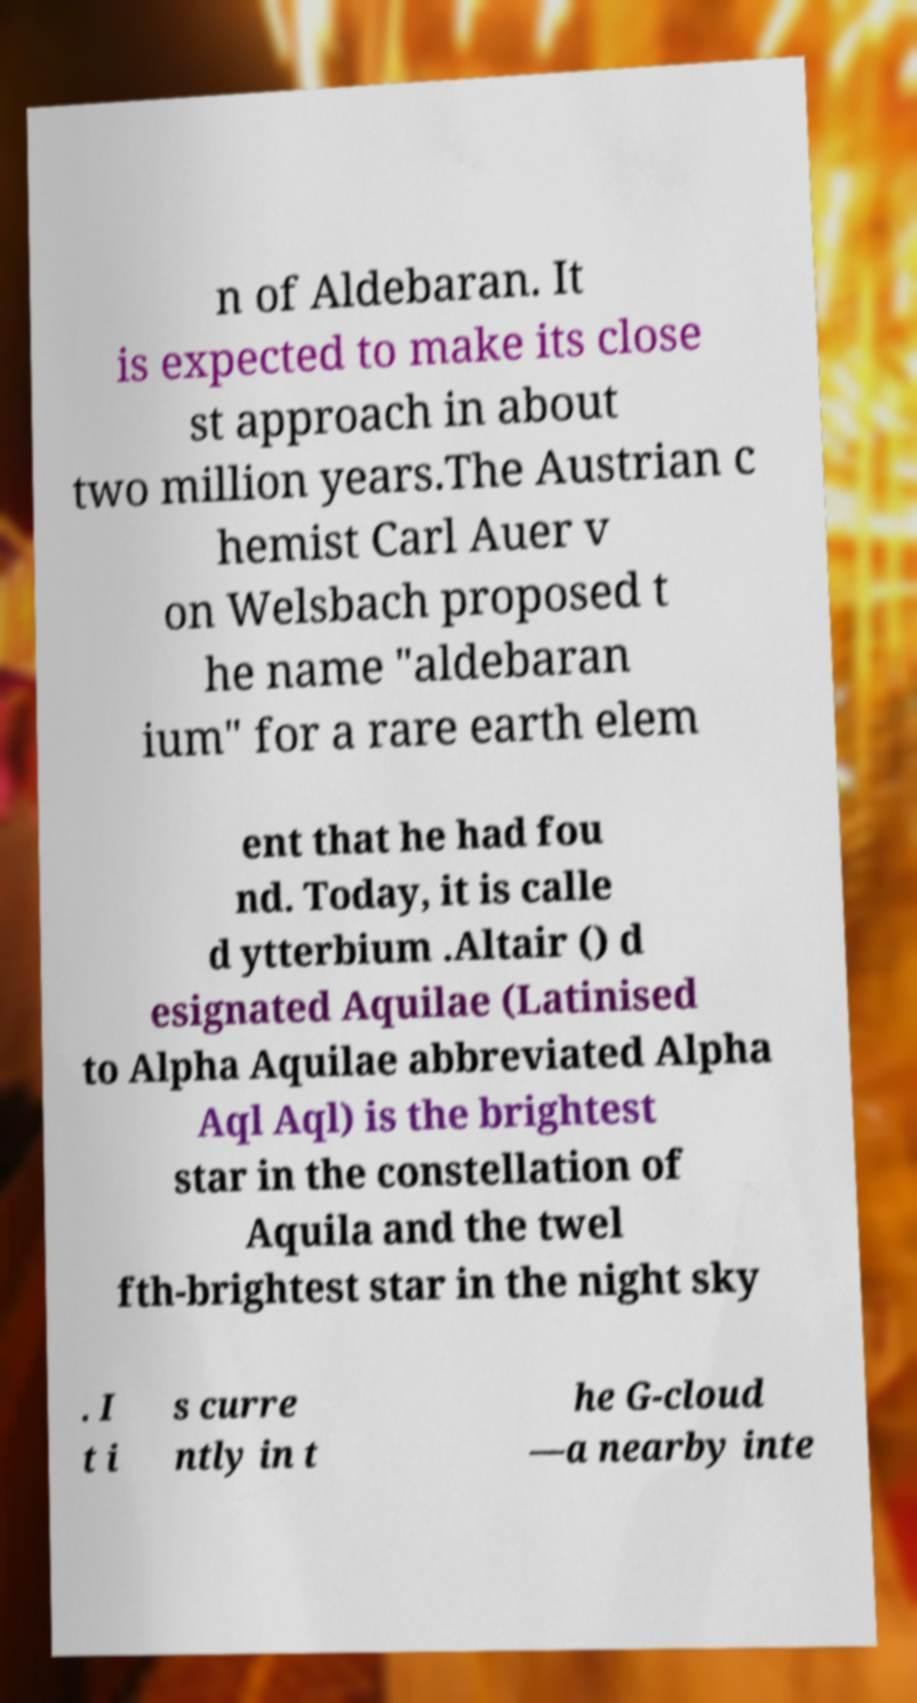I need the written content from this picture converted into text. Can you do that? n of Aldebaran. It is expected to make its close st approach in about two million years.The Austrian c hemist Carl Auer v on Welsbach proposed t he name "aldebaran ium" for a rare earth elem ent that he had fou nd. Today, it is calle d ytterbium .Altair () d esignated Aquilae (Latinised to Alpha Aquilae abbreviated Alpha Aql Aql) is the brightest star in the constellation of Aquila and the twel fth-brightest star in the night sky . I t i s curre ntly in t he G-cloud —a nearby inte 